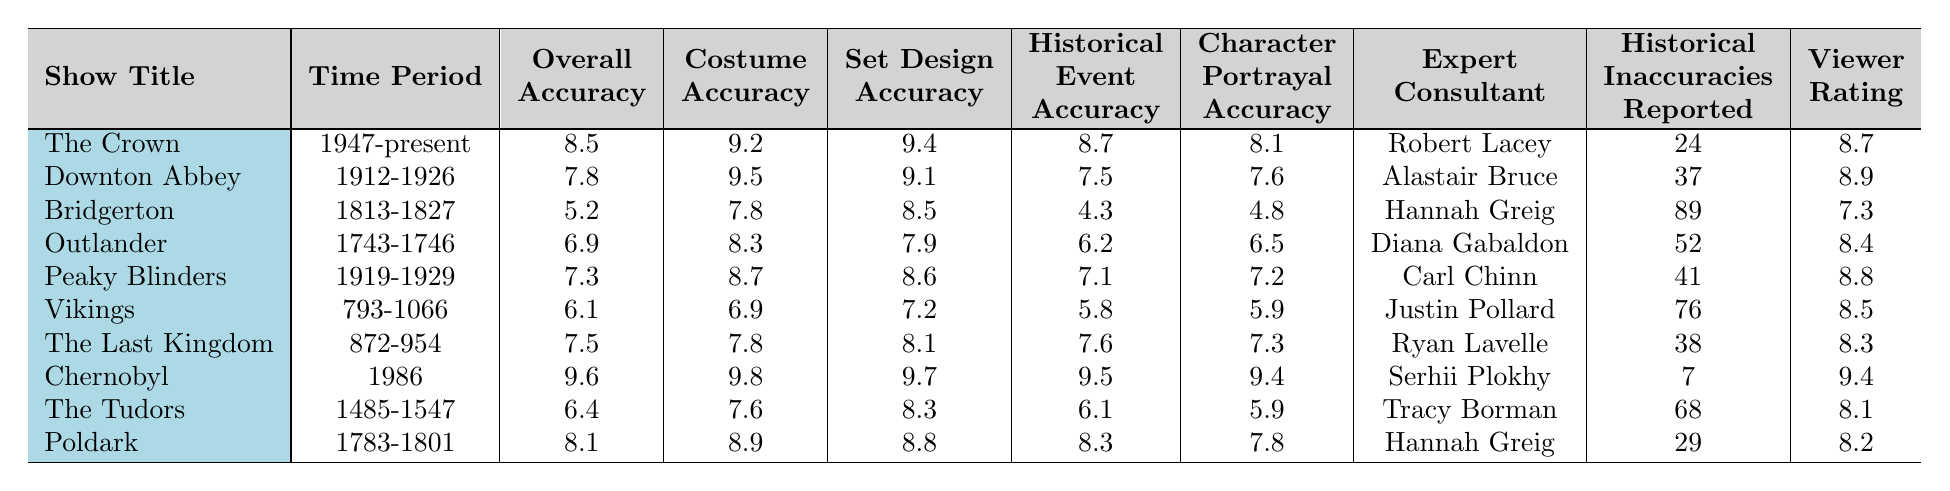What is the overall accuracy score of "Chernobyl"? By locating "Chernobyl" in the table, we find the corresponding overall accuracy score listed is 9.6.
Answer: 9.6 Which show has the highest costume accuracy rating? In the costume accuracy column, "Chernobyl" has the highest score of 9.8, compared to the other shows.
Answer: Chernobyl What is the average set design accuracy for the shows set in the 20th century? The shows set in the 20th century are "Downton Abbey," "Peaky Blinders," "Vikings," and "Chernobyl." Their set design accuracy scores are 9.1, 8.6, 7.2, and 9.7 respectively. The average is calculated as (9.1 + 8.6 + 7.2 + 9.7) / 4 = 8.65.
Answer: 8.65 How many historical inaccuracies were reported for "Bridgerton"? Looking at the row for "Bridgerton," we can see that the number of historical inaccuracies reported is 89.
Answer: 89 Is the viewer rating for "The Last Kingdom" higher than the overall accuracy score? The viewer rating for "The Last Kingdom" is 8.3, while the overall accuracy score is 7.5. Since 8.3 is greater than 7.5, the statement is true.
Answer: Yes Which show has the lowest character portrayal accuracy? Scanning the character portrayal accuracy column reveals "Bridgerton" with a score of 4.8, the lowest among all shows.
Answer: Bridgerton What is the sum of historical inaccuracies reported for all shows? Adding the historical inaccuracies from each show gives us 24 + 37 + 89 + 52 + 41 + 76 + 38 + 7 + 68 + 29 = 461.
Answer: 461 Which time period has the greatest average viewer rating? The average viewer ratings can be calculated for each unique time period. The ratings per period are: 1947-present (8.7), 1912-1926 (8.9), 1813-1827 (7.3), 1743-1746 (8.4), 1919-1929 (8.8), 793-1066 (8.5), 872-954 (8.3), 1986 (9.4), 1485-1547 (8.1), and 1783-1801 (8.2). The period with the highest average viewer rating is 1986, with a score of 9.4.
Answer: 1986 Which expert consultant worked on both "Poldark" and "Bridgerton"? Looking at the expert consultants listed, "Hannah Greig" is noted for both "Poldark" and "Bridgerton."
Answer: Hannah Greig What is the difference between overall accuracy scores of "The Crown" and "The Tudors"? The overall accuracy score for "The Crown" is 8.5 and for "The Tudors," it is 6.4. The difference is calculated as 8.5 - 6.4 = 2.1.
Answer: 2.1 